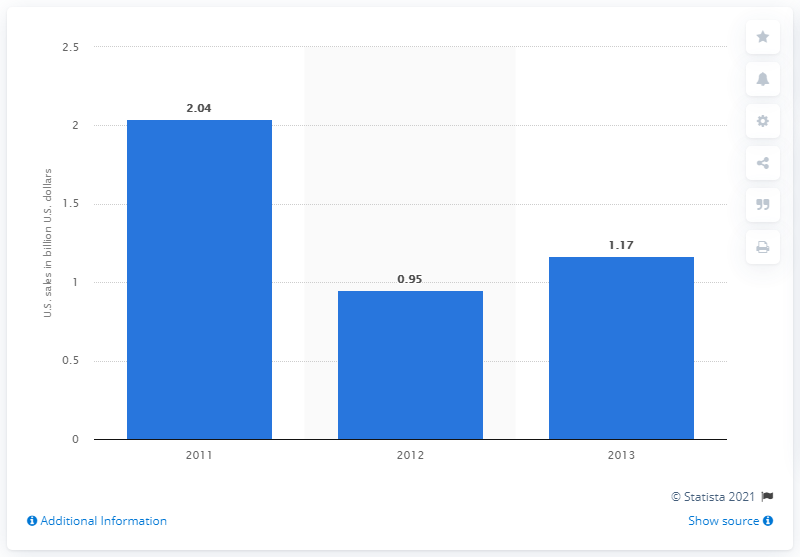Draw attention to some important aspects in this diagram. In 2012, the sales of Buffalo Wild Wings were 0.95. In 2013, Buffalo Wild Wings sold 1.17 billion dollars worth of products in the United States. 